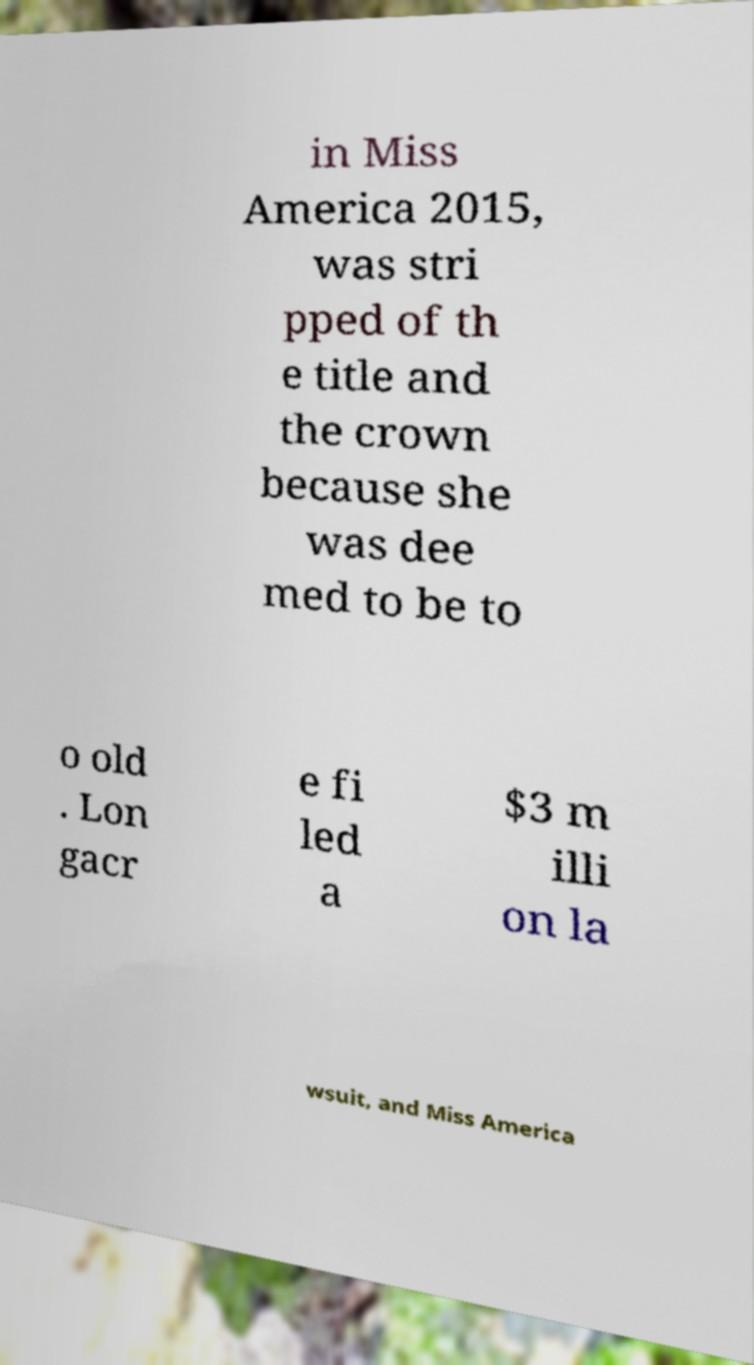Could you extract and type out the text from this image? in Miss America 2015, was stri pped of th e title and the crown because she was dee med to be to o old . Lon gacr e fi led a $3 m illi on la wsuit, and Miss America 